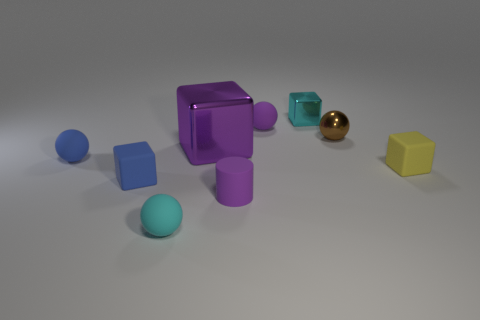There is a cylinder that is the same color as the big block; what material is it?
Your answer should be very brief. Rubber. What material is the small purple object that is the same shape as the brown thing?
Your answer should be very brief. Rubber. There is a brown metal object that is the same size as the cyan rubber sphere; what is its shape?
Offer a terse response. Sphere. Is there a small matte thing of the same shape as the large object?
Your answer should be compact. Yes. There is a purple object in front of the small matte cube that is left of the tiny cyan shiny block; what is its shape?
Your answer should be very brief. Cylinder. What shape is the small cyan matte object?
Provide a succinct answer. Sphere. There is a ball right of the thing behind the small purple object behind the small yellow rubber cube; what is it made of?
Keep it short and to the point. Metal. How many other objects are the same material as the large object?
Offer a very short reply. 2. There is a small block right of the brown object; how many small blue balls are in front of it?
Give a very brief answer. 0. How many spheres are small matte things or brown metal things?
Keep it short and to the point. 4. 